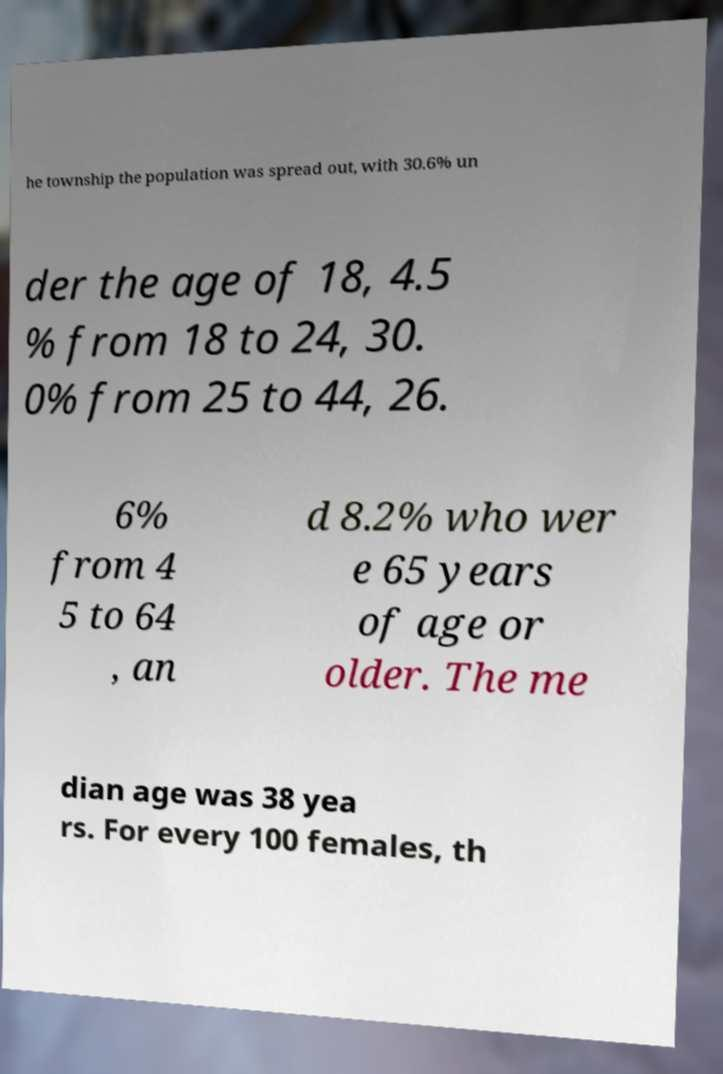For documentation purposes, I need the text within this image transcribed. Could you provide that? he township the population was spread out, with 30.6% un der the age of 18, 4.5 % from 18 to 24, 30. 0% from 25 to 44, 26. 6% from 4 5 to 64 , an d 8.2% who wer e 65 years of age or older. The me dian age was 38 yea rs. For every 100 females, th 